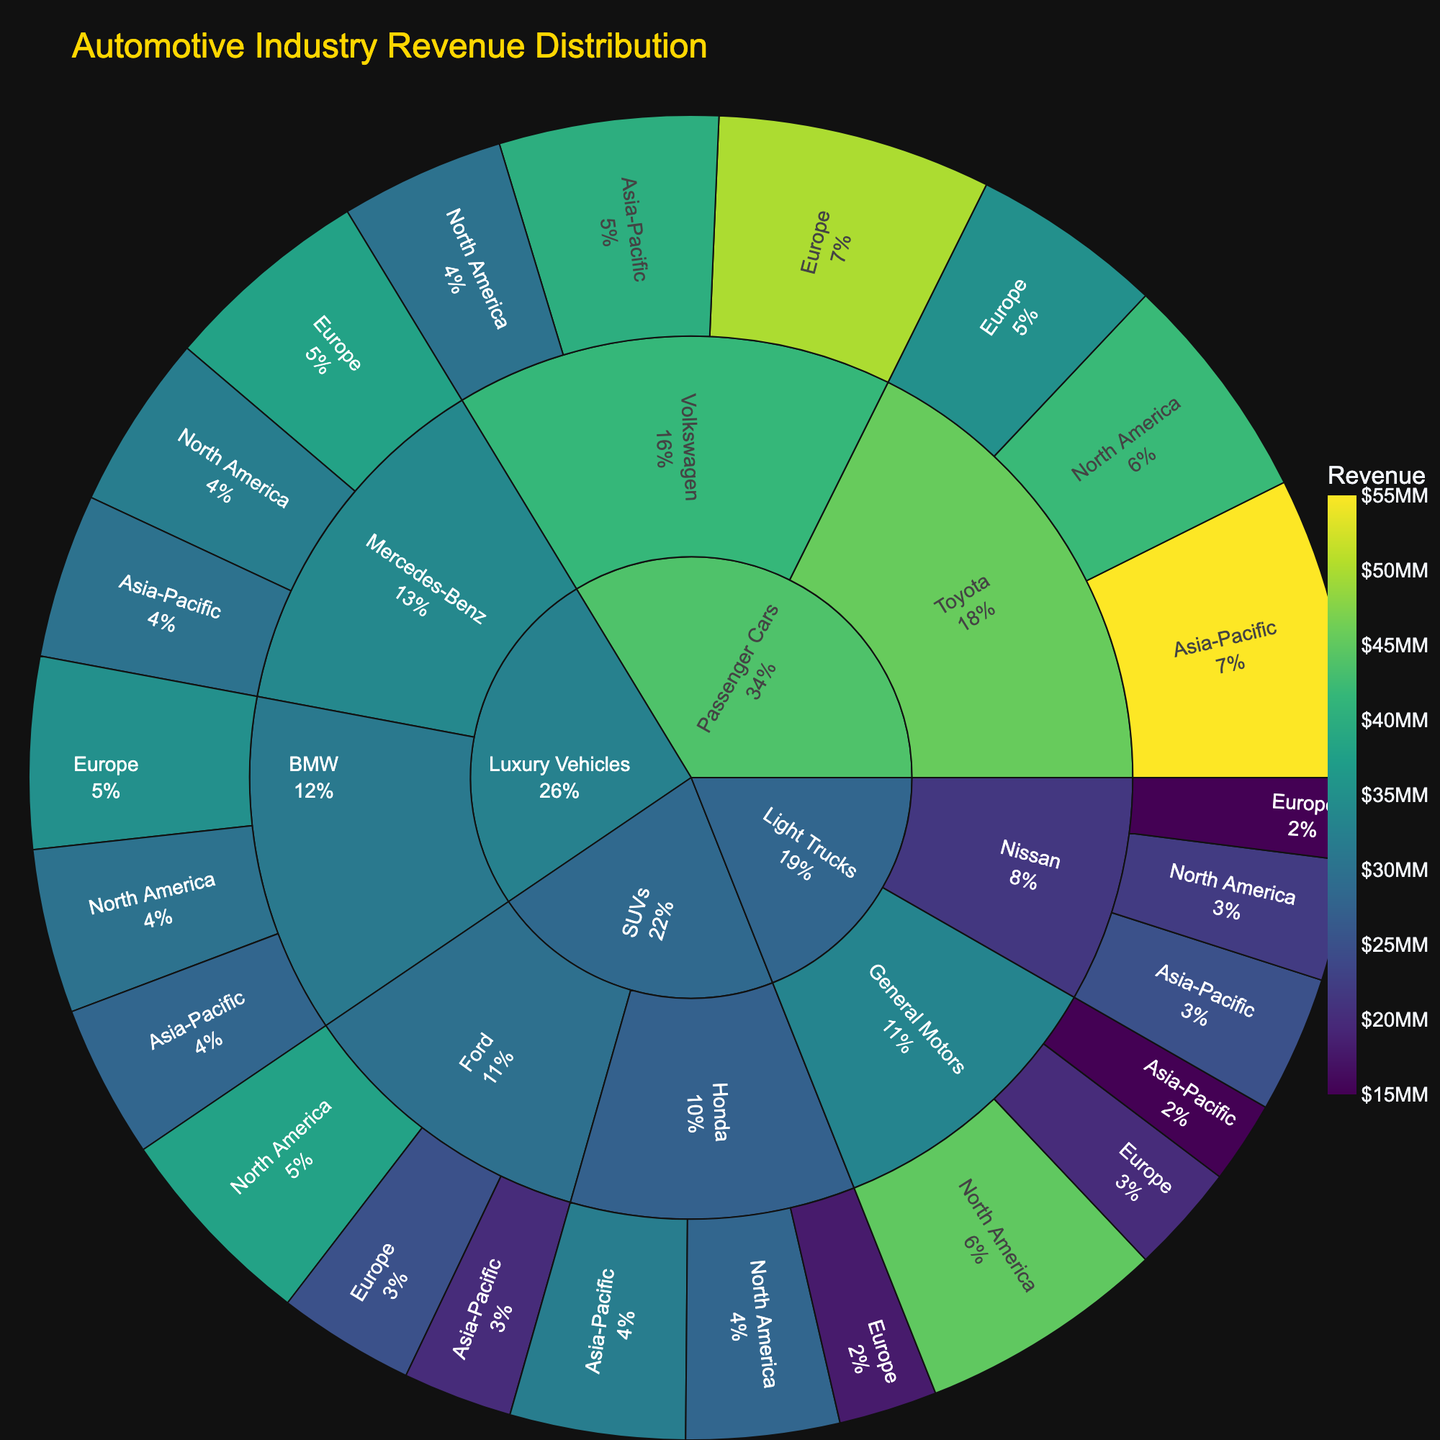What is the title of the sunburst plot? The title is usually positioned at the top of the chart and summarizes what the visual represents. The title "Automotive Industry Revenue Distribution" indicates that the plot visualizes how the revenue is distributed across different vehicle types, manufacturers, and geographical markets.
Answer: Automotive Industry Revenue Distribution Which vehicle type has the highest revenue in the North American market? Look for the segment labeled "North America" and then trace back to its parent segments to identify the vehicle type with the highest revenue. "Light Trucks" by General Motors has the highest revenue of $45,000,000.
Answer: Light Trucks How much total revenue does Toyota generate across all geographical markets? Sum the revenue values for Toyota across North America, Europe, and Asia-Pacific. The total is $42,000,000 + $35,000,000 + $55,000,000.
Answer: $132,000,000 Which manufacturer contributes the most to the revenue of Luxury Vehicles in Europe? Identify the segments under Luxury Vehicles in Europe and compare the revenues of BMW and Mercedes-Benz. Mercedes-Benz leads with $38,000,000 in Europe.
Answer: Mercedes-Benz What is the combined revenue of Honda SUVs in North America and Asia-Pacific? Add the revenue values for Honda SUVs in these two markets: $28,000,000 (North America) + $32,000,000 (Asia-Pacific).
Answer: $60,000,000 Between General Motors and Ford, which manufacturer has a higher revenue in the Asia-Pacific market? Compare the Asia-Pacific revenues of General Motors and Ford. General Motors has $15,000,000 while Ford has $20,000,000.
Answer: Ford Which geographical market generates the most revenue for Volkswagen's Passenger Cars? Look at the segments under Volkswagen's Passenger Cars and compare the revenues for each geographical market. Europe has the highest revenue of $50,000,000.
Answer: Europe What is the average revenue for Nissan's Light Trucks across all regions? Calculate the average by summing the revenues and then dividing by the number of regions: ($22,000,000 + $15,000,000 + $25,000,000) / 3.
Answer: $20,666,667 How does the revenue of BMW in the Asia-Pacific market compare to that in North America? Compare the revenue values for BMW in these two markets: Asia-Pacific ($28,000,000) and North America ($30,000,000). Notice that BMW's revenue is higher in North America.
Answer: North America Within the Passenger Cars category, which manufacturer has the highest overall revenue? Sum up the revenue values for each manufacturer within the Passenger Cars category and compare. Volkswagen totals $120,000,000, while Toyota totals $132,000,000. Toyota has the highest overall revenue.
Answer: Toyota 